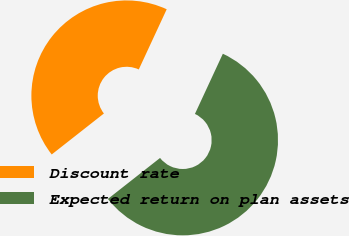Convert chart to OTSL. <chart><loc_0><loc_0><loc_500><loc_500><pie_chart><fcel>Discount rate<fcel>Expected return on plan assets<nl><fcel>42.51%<fcel>57.49%<nl></chart> 